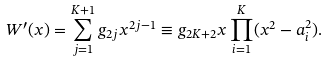<formula> <loc_0><loc_0><loc_500><loc_500>W ^ { \prime } ( x ) = \sum _ { j = 1 } ^ { K + 1 } g _ { 2 j } x ^ { 2 j - 1 } \equiv g _ { 2 K + 2 } x \prod _ { i = 1 } ^ { K } ( x ^ { 2 } - a _ { i } ^ { 2 } ) .</formula> 